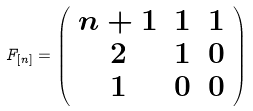<formula> <loc_0><loc_0><loc_500><loc_500>F _ { [ n ] } = \left ( \begin{array} { c c c } n + 1 & 1 & 1 \\ 2 & 1 & 0 \\ 1 & 0 & 0 \\ \end{array} \right )</formula> 